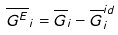<formula> <loc_0><loc_0><loc_500><loc_500>\overline { G ^ { E } } _ { i } = \overline { G } _ { i } - \overline { G } _ { i } ^ { i d }</formula> 